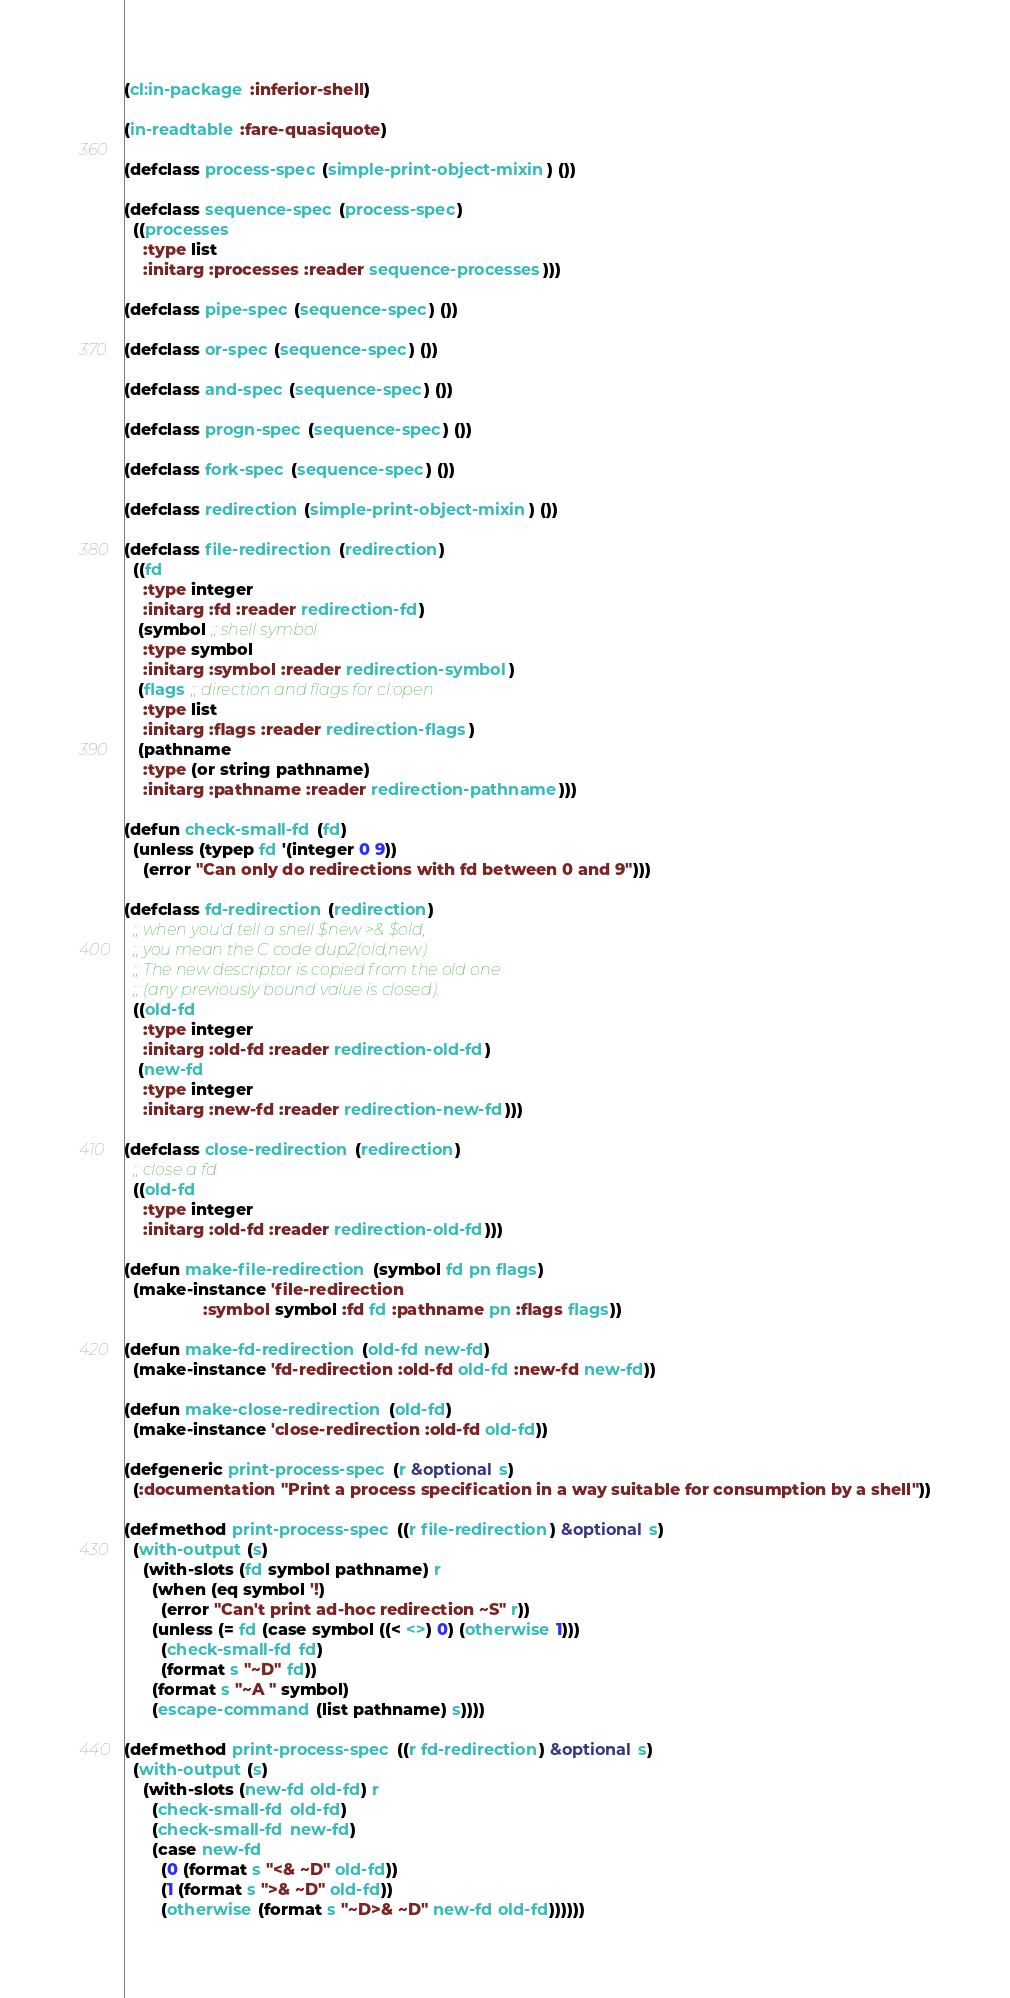Convert code to text. <code><loc_0><loc_0><loc_500><loc_500><_Lisp_>(cl:in-package :inferior-shell)

(in-readtable :fare-quasiquote)

(defclass process-spec (simple-print-object-mixin) ())

(defclass sequence-spec (process-spec)
  ((processes
    :type list
    :initarg :processes :reader sequence-processes)))

(defclass pipe-spec (sequence-spec) ())

(defclass or-spec (sequence-spec) ())

(defclass and-spec (sequence-spec) ())

(defclass progn-spec (sequence-spec) ())

(defclass fork-spec (sequence-spec) ())

(defclass redirection (simple-print-object-mixin) ())

(defclass file-redirection (redirection)
  ((fd
    :type integer
    :initarg :fd :reader redirection-fd)
   (symbol ;; shell symbol
    :type symbol
    :initarg :symbol :reader redirection-symbol)
   (flags ;; direction and flags for cl:open
    :type list
    :initarg :flags :reader redirection-flags)
   (pathname
    :type (or string pathname)
    :initarg :pathname :reader redirection-pathname)))

(defun check-small-fd (fd)
  (unless (typep fd '(integer 0 9))
    (error "Can only do redirections with fd between 0 and 9")))

(defclass fd-redirection (redirection)
  ;; when you'd tell a shell $new >& $old,
  ;; you mean the C code dup2(old,new)
  ;; The new descriptor is copied from the old one
  ;; (any previously bound value is closed).
  ((old-fd
    :type integer
    :initarg :old-fd :reader redirection-old-fd)
   (new-fd
    :type integer
    :initarg :new-fd :reader redirection-new-fd)))

(defclass close-redirection (redirection)
  ;; close a fd
  ((old-fd
    :type integer
    :initarg :old-fd :reader redirection-old-fd)))

(defun make-file-redirection (symbol fd pn flags)
  (make-instance 'file-redirection
                 :symbol symbol :fd fd :pathname pn :flags flags))

(defun make-fd-redirection (old-fd new-fd)
  (make-instance 'fd-redirection :old-fd old-fd :new-fd new-fd))

(defun make-close-redirection (old-fd)
  (make-instance 'close-redirection :old-fd old-fd))

(defgeneric print-process-spec (r &optional s)
  (:documentation "Print a process specification in a way suitable for consumption by a shell"))

(defmethod print-process-spec ((r file-redirection) &optional s)
  (with-output (s)
    (with-slots (fd symbol pathname) r
      (when (eq symbol '!)
        (error "Can't print ad-hoc redirection ~S" r))
      (unless (= fd (case symbol ((< <>) 0) (otherwise 1)))
        (check-small-fd fd)
        (format s "~D" fd))
      (format s "~A " symbol)
      (escape-command (list pathname) s))))

(defmethod print-process-spec ((r fd-redirection) &optional s)
  (with-output (s)
    (with-slots (new-fd old-fd) r
      (check-small-fd old-fd)
      (check-small-fd new-fd)
      (case new-fd
        (0 (format s "<& ~D" old-fd))
        (1 (format s ">& ~D" old-fd))
        (otherwise (format s "~D>& ~D" new-fd old-fd))))))
</code> 